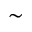<formula> <loc_0><loc_0><loc_500><loc_500>\sim</formula> 